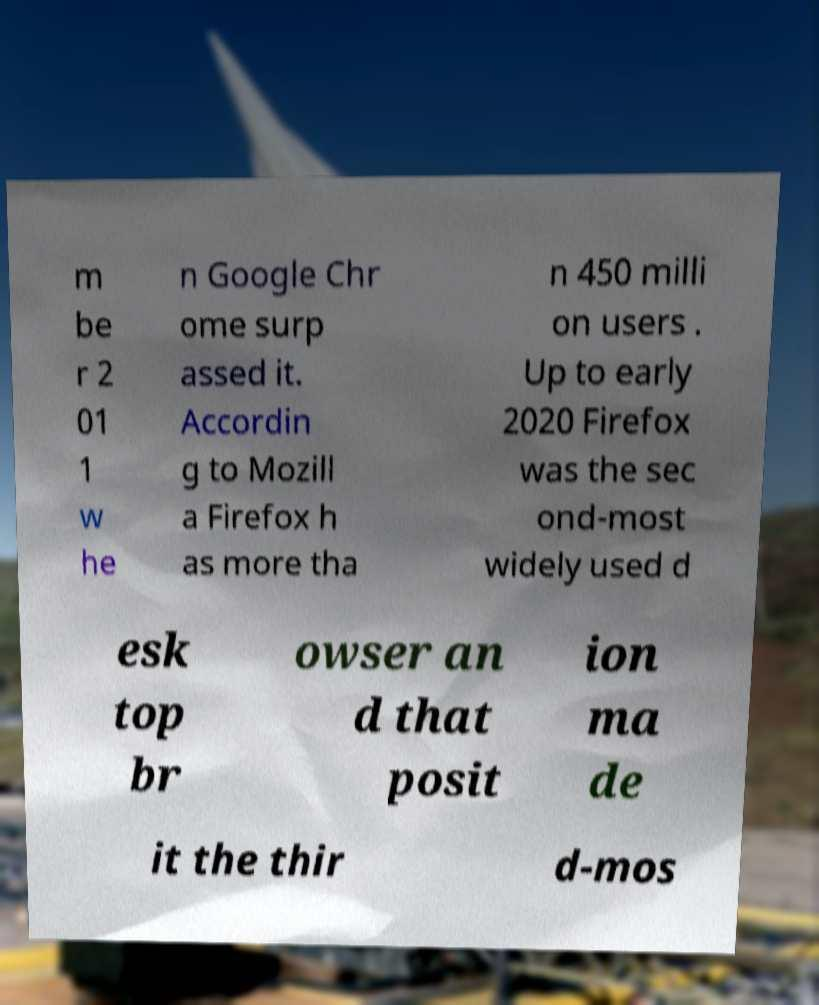What messages or text are displayed in this image? I need them in a readable, typed format. m be r 2 01 1 w he n Google Chr ome surp assed it. Accordin g to Mozill a Firefox h as more tha n 450 milli on users . Up to early 2020 Firefox was the sec ond-most widely used d esk top br owser an d that posit ion ma de it the thir d-mos 